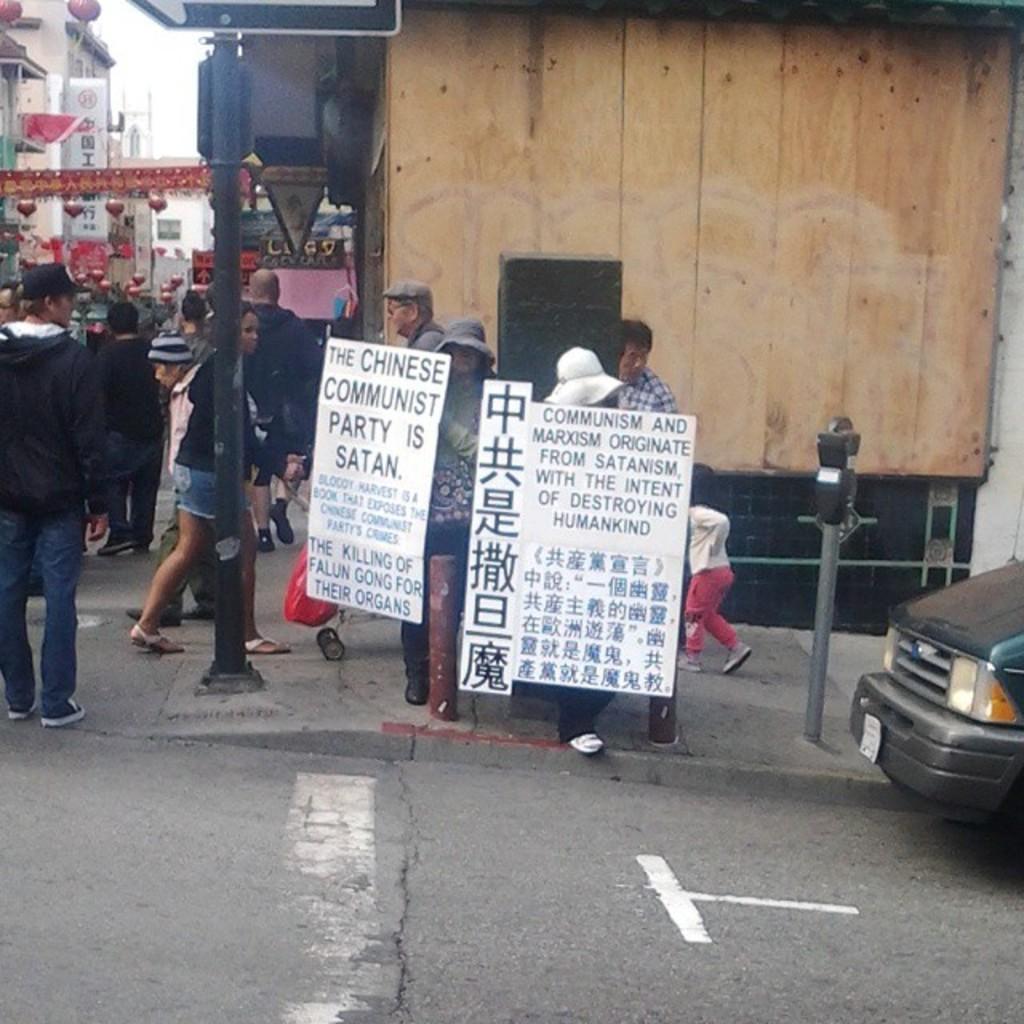In one or two sentences, can you explain what this image depicts? In this image I can see the group of people with different color dresses. I can see few people are holding the boards. To the right I can see the vehicle and the pole. In the background I can see the buildings, banners and the sky. 